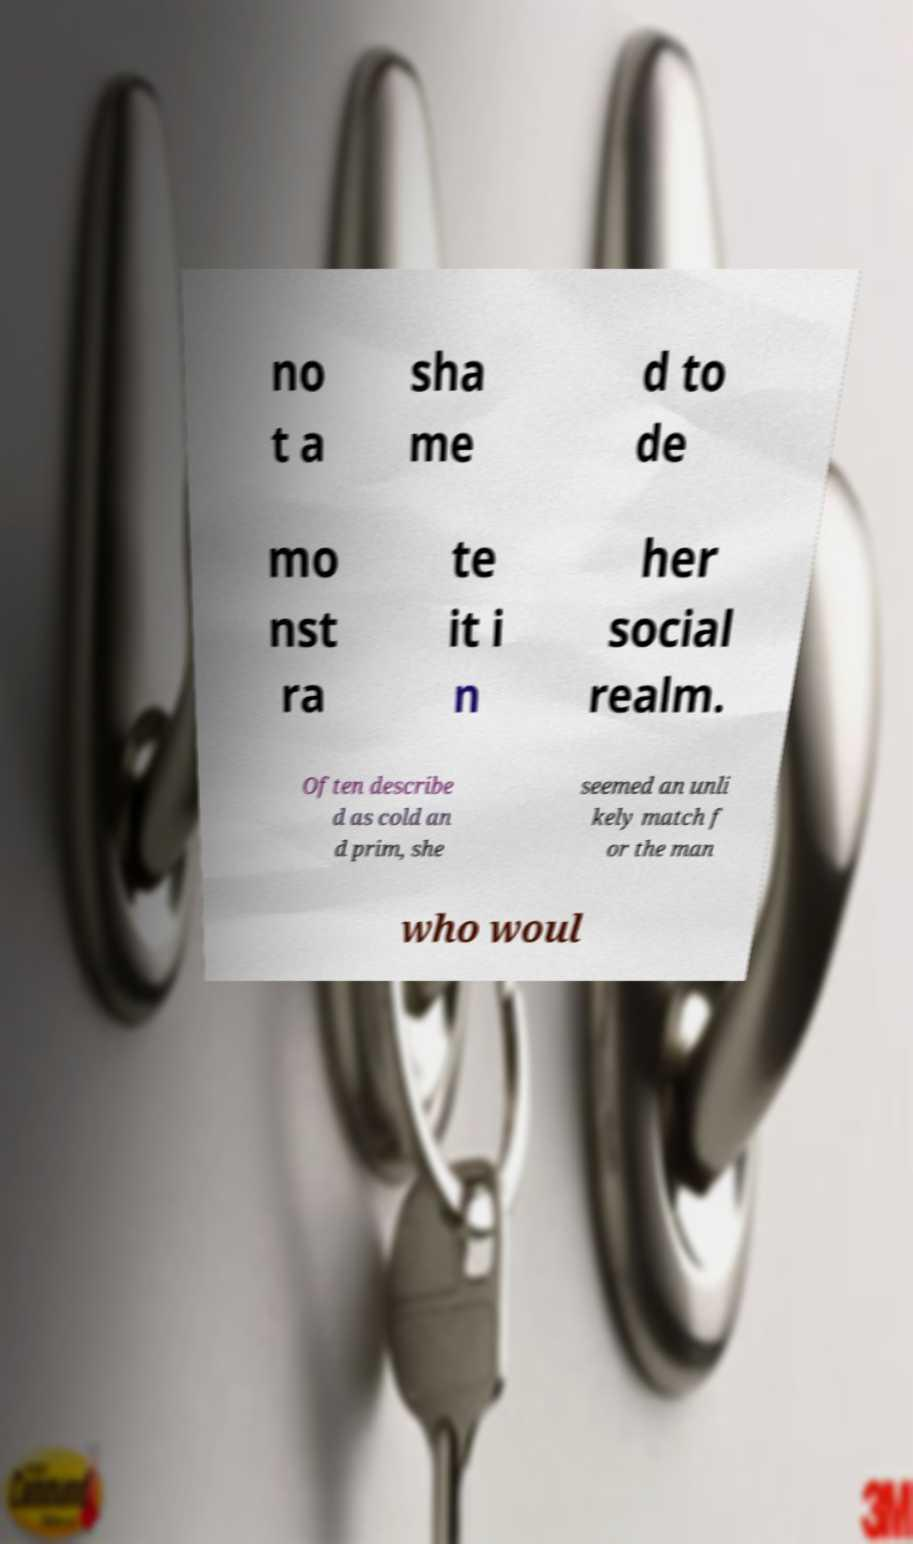Can you read and provide the text displayed in the image?This photo seems to have some interesting text. Can you extract and type it out for me? no t a sha me d to de mo nst ra te it i n her social realm. Often describe d as cold an d prim, she seemed an unli kely match f or the man who woul 